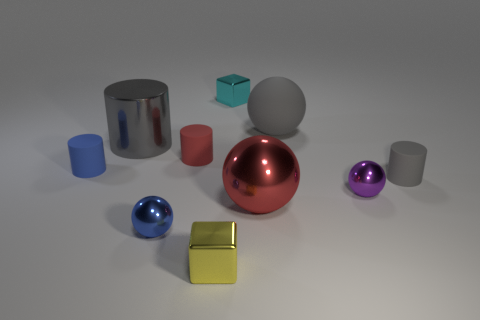Subtract all red matte cylinders. How many cylinders are left? 3 Subtract 1 blocks. How many blocks are left? 1 Subtract all spheres. How many objects are left? 6 Subtract all gray cylinders. How many cylinders are left? 2 Subtract 0 green blocks. How many objects are left? 10 Subtract all green cubes. Subtract all green cylinders. How many cubes are left? 2 Subtract all blue spheres. How many cyan cylinders are left? 0 Subtract all brown rubber things. Subtract all gray matte spheres. How many objects are left? 9 Add 8 tiny yellow metallic things. How many tiny yellow metallic things are left? 9 Add 3 small purple spheres. How many small purple spheres exist? 4 